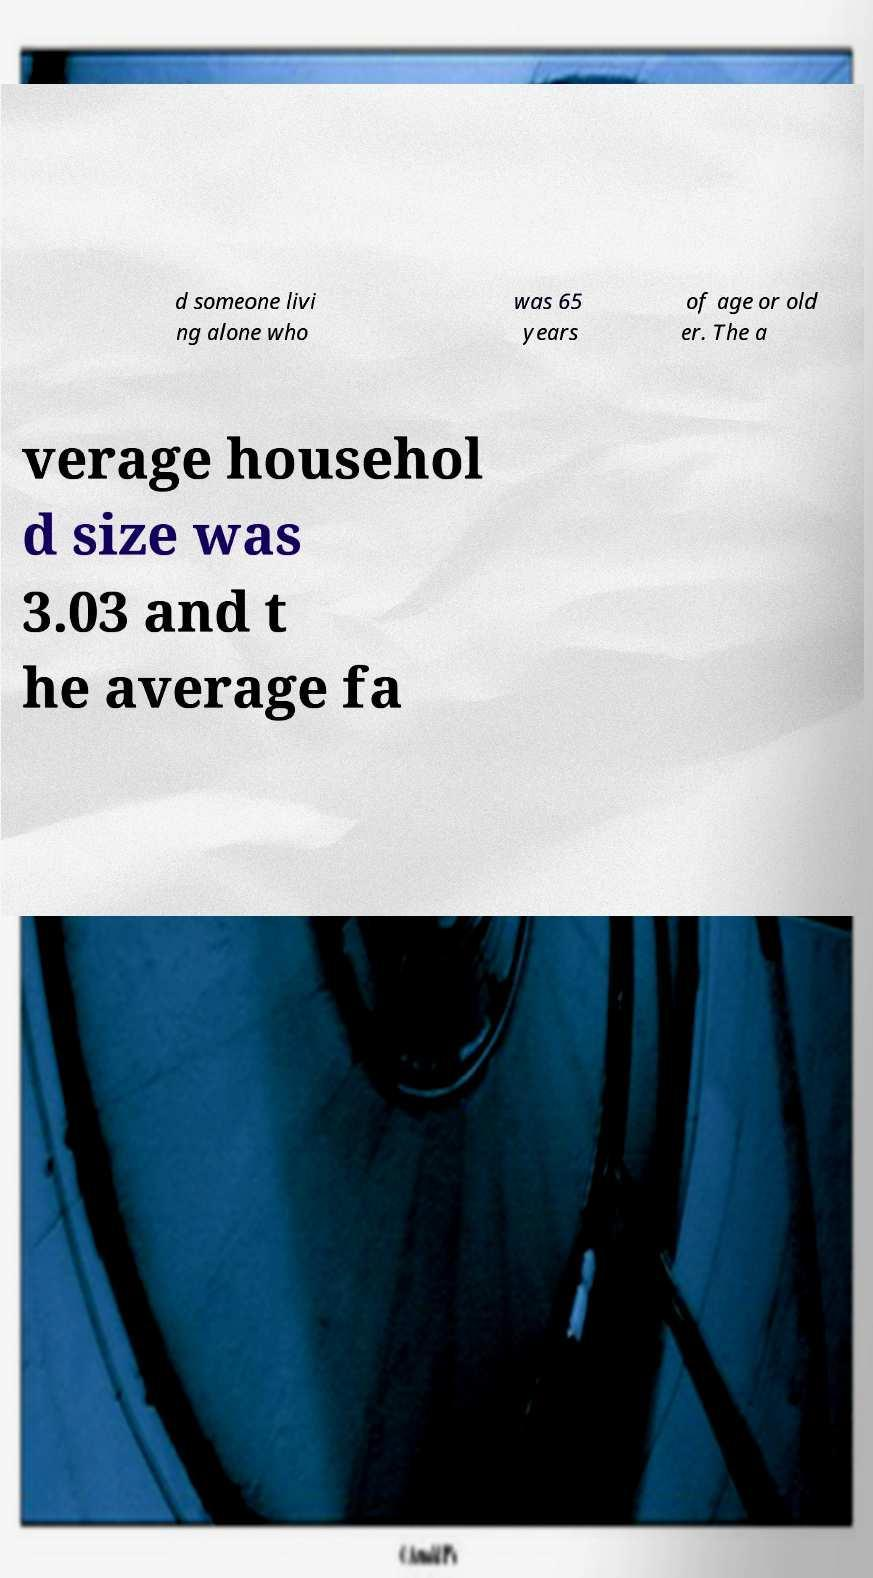Can you accurately transcribe the text from the provided image for me? d someone livi ng alone who was 65 years of age or old er. The a verage househol d size was 3.03 and t he average fa 